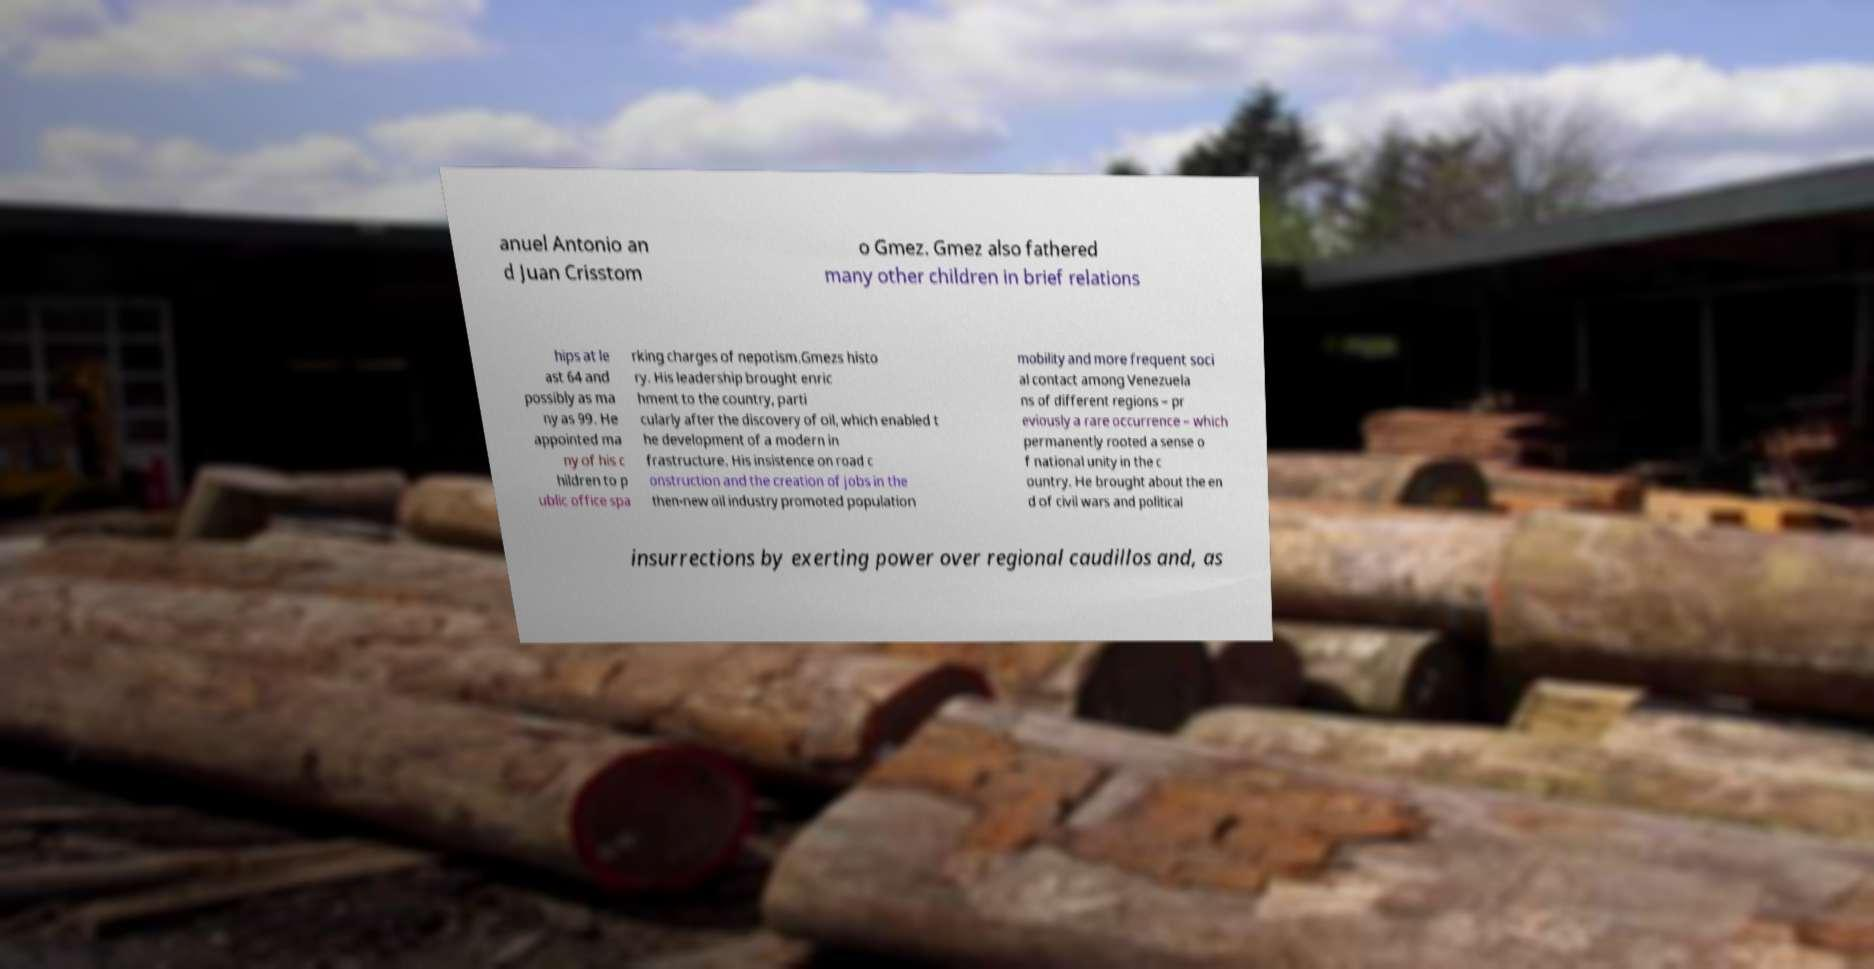Can you accurately transcribe the text from the provided image for me? anuel Antonio an d Juan Crisstom o Gmez. Gmez also fathered many other children in brief relations hips at le ast 64 and possibly as ma ny as 99. He appointed ma ny of his c hildren to p ublic office spa rking charges of nepotism.Gmezs histo ry. His leadership brought enric hment to the country, parti cularly after the discovery of oil, which enabled t he development of a modern in frastructure. His insistence on road c onstruction and the creation of jobs in the then-new oil industry promoted population mobility and more frequent soci al contact among Venezuela ns of different regions – pr eviously a rare occurrence – which permanently rooted a sense o f national unity in the c ountry. He brought about the en d of civil wars and political insurrections by exerting power over regional caudillos and, as 